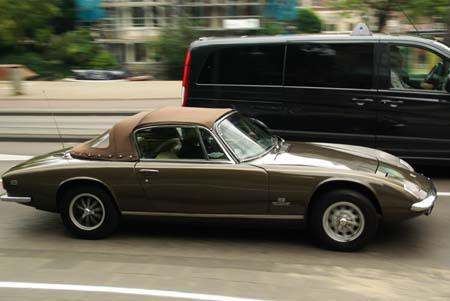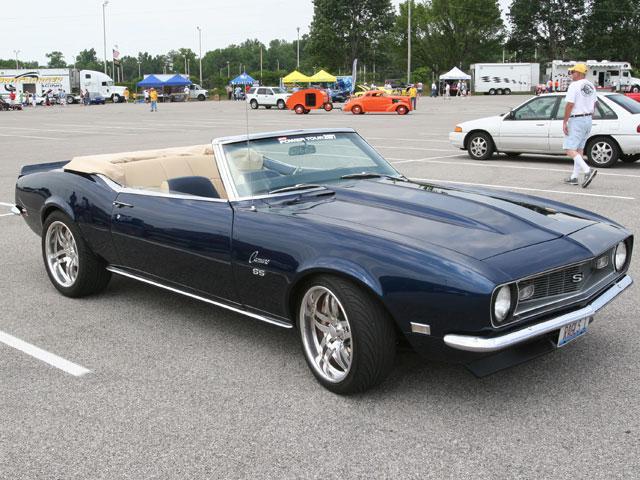The first image is the image on the left, the second image is the image on the right. For the images displayed, is the sentence "One image shows a blue convertible with the top down." factually correct? Answer yes or no. Yes. 